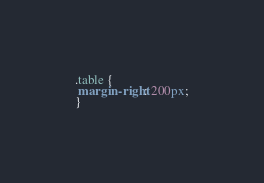<code> <loc_0><loc_0><loc_500><loc_500><_CSS_>.table {
 margin-right: 200px;
}
</code> 